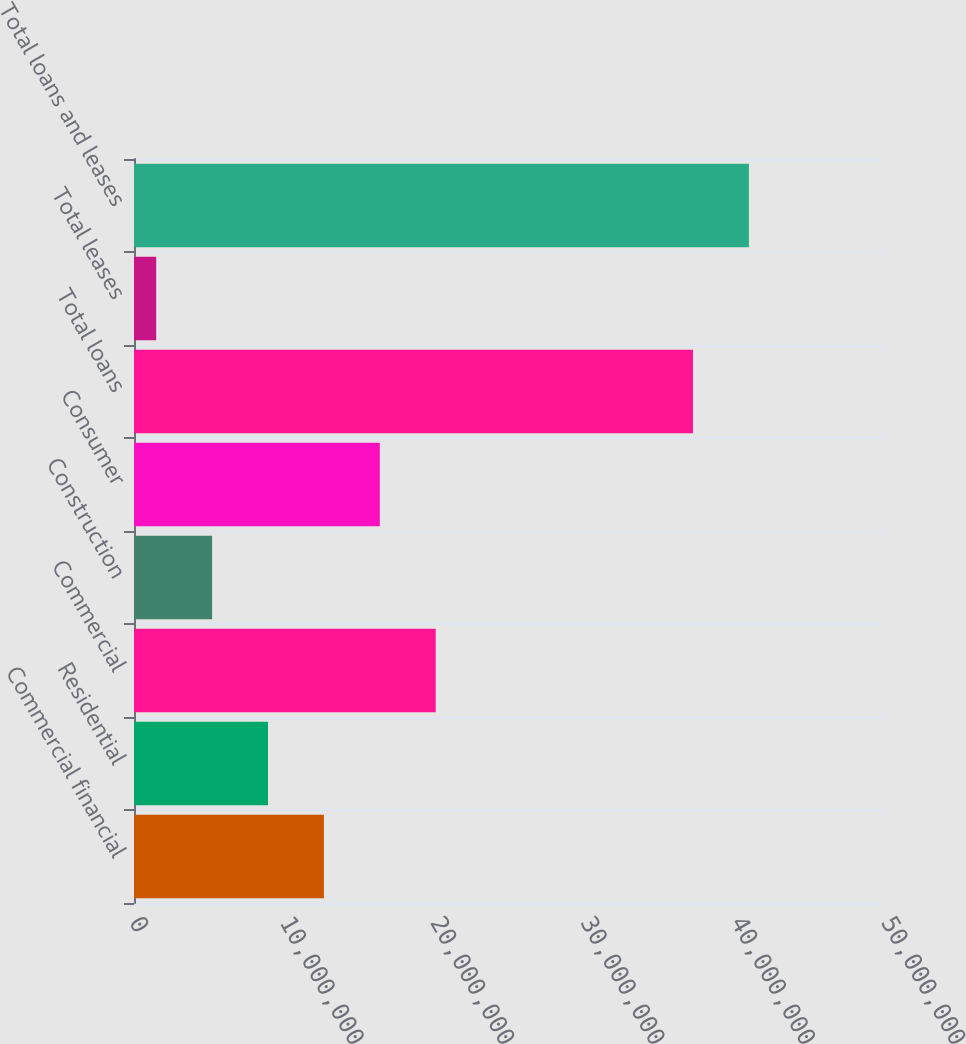Convert chart to OTSL. <chart><loc_0><loc_0><loc_500><loc_500><bar_chart><fcel>Commercial financial<fcel>Residential<fcel>Commercial<fcel>Construction<fcel>Consumer<fcel>Total loans<fcel>Total leases<fcel>Total loans and leases<nl><fcel>1.26266e+07<fcel>8.90971e+06<fcel>2.00603e+07<fcel>5.19285e+06<fcel>1.63434e+07<fcel>3.71686e+07<fcel>1.47599e+06<fcel>4.08855e+07<nl></chart> 